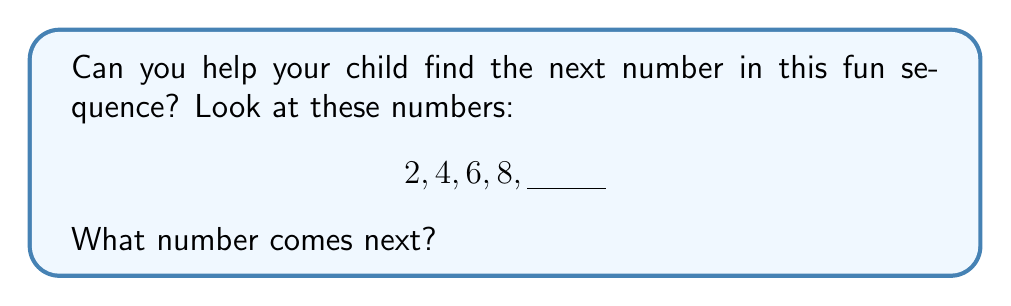What is the answer to this math problem? Let's break this down step-by-step:

1. First, we need to look at the numbers we have: 2, 4, 6, 8

2. Now, let's see how these numbers are changing:
   - From 2 to 4: $4 - 2 = 2$
   - From 4 to 6: $6 - 4 = 2$
   - From 6 to 8: $8 - 6 = 2$

3. We can see that each number is increasing by 2.

4. So, to find the next number, we need to add 2 to the last number we have:
   $8 + 2 = 10$

Therefore, the next number in the sequence should be 10.
Answer: 10 